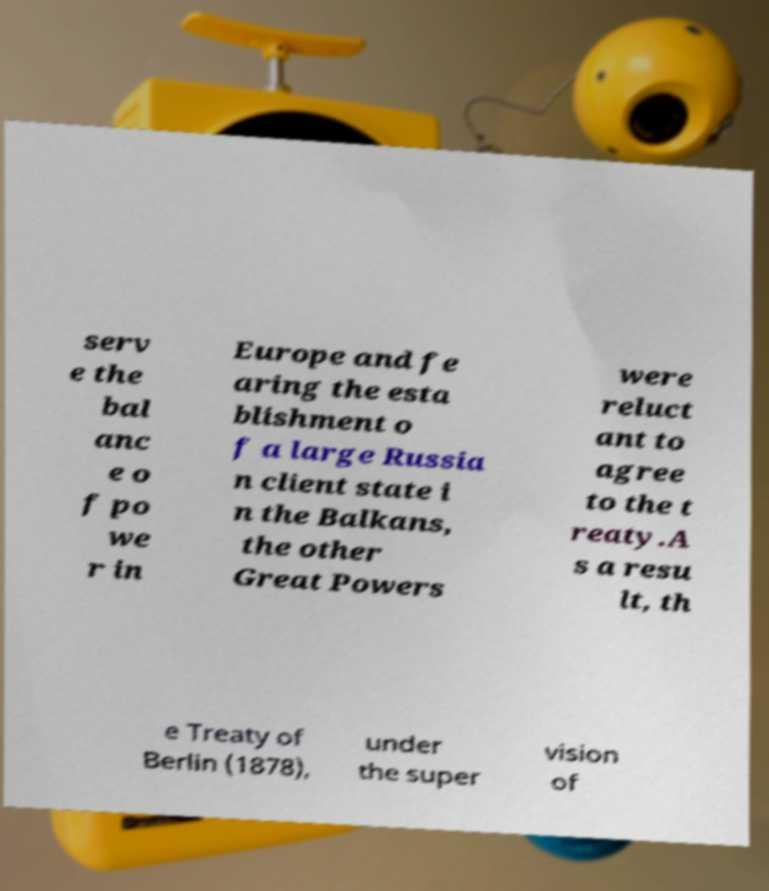Please read and relay the text visible in this image. What does it say? serv e the bal anc e o f po we r in Europe and fe aring the esta blishment o f a large Russia n client state i n the Balkans, the other Great Powers were reluct ant to agree to the t reaty.A s a resu lt, th e Treaty of Berlin (1878), under the super vision of 